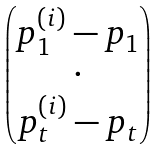<formula> <loc_0><loc_0><loc_500><loc_500>\begin{pmatrix} p _ { 1 } ^ { ( i ) } - p _ { 1 } \\ \cdot \\ p _ { t } ^ { ( i ) } - p _ { t } \end{pmatrix}</formula> 